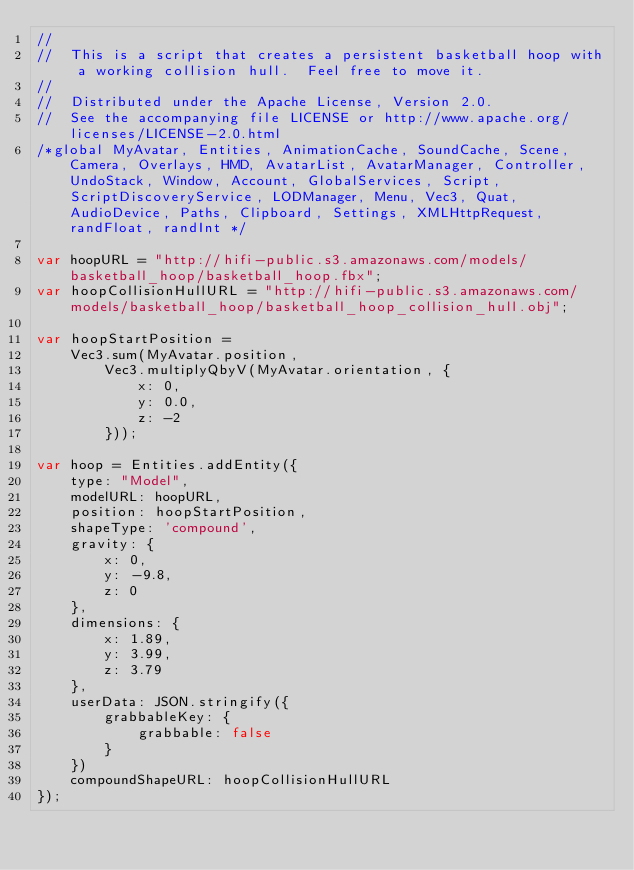<code> <loc_0><loc_0><loc_500><loc_500><_JavaScript_>//
//  This is a script that creates a persistent basketball hoop with a working collision hull.  Feel free to move it.
//
//  Distributed under the Apache License, Version 2.0.
//  See the accompanying file LICENSE or http://www.apache.org/licenses/LICENSE-2.0.html
/*global MyAvatar, Entities, AnimationCache, SoundCache, Scene, Camera, Overlays, HMD, AvatarList, AvatarManager, Controller, UndoStack, Window, Account, GlobalServices, Script, ScriptDiscoveryService, LODManager, Menu, Vec3, Quat, AudioDevice, Paths, Clipboard, Settings, XMLHttpRequest, randFloat, randInt */

var hoopURL = "http://hifi-public.s3.amazonaws.com/models/basketball_hoop/basketball_hoop.fbx";
var hoopCollisionHullURL = "http://hifi-public.s3.amazonaws.com/models/basketball_hoop/basketball_hoop_collision_hull.obj";

var hoopStartPosition =
    Vec3.sum(MyAvatar.position,
        Vec3.multiplyQbyV(MyAvatar.orientation, {
            x: 0,
            y: 0.0,
            z: -2
        }));

var hoop = Entities.addEntity({
    type: "Model",
    modelURL: hoopURL,
    position: hoopStartPosition,
    shapeType: 'compound',
    gravity: {
        x: 0,
        y: -9.8,
        z: 0
    },
    dimensions: {
        x: 1.89,
        y: 3.99,
        z: 3.79
    },
    userData: JSON.stringify({
        grabbableKey: {
            grabbable: false
        }
    })
    compoundShapeURL: hoopCollisionHullURL
});</code> 